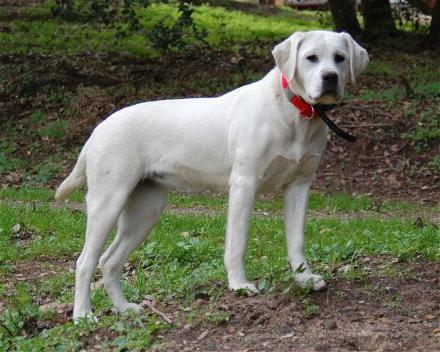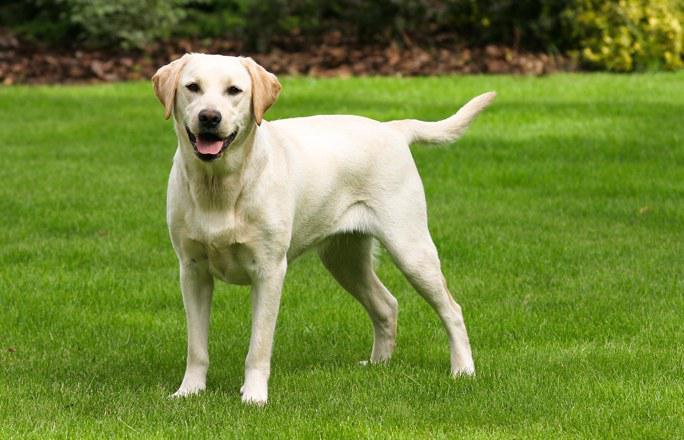The first image is the image on the left, the second image is the image on the right. Examine the images to the left and right. Is the description "The combined images include two standing dogs, with at least one of them wearing a collar but no pack." accurate? Answer yes or no. Yes. The first image is the image on the left, the second image is the image on the right. Considering the images on both sides, is "The left image contains exactly two dogs." valid? Answer yes or no. No. 